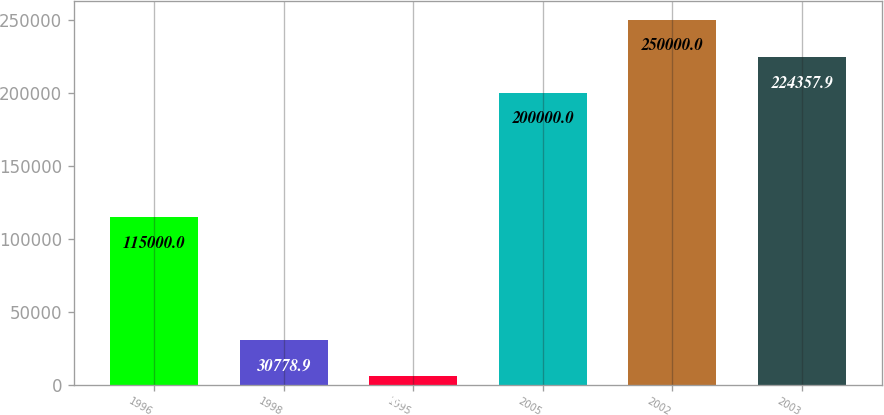Convert chart to OTSL. <chart><loc_0><loc_0><loc_500><loc_500><bar_chart><fcel>1996<fcel>1998<fcel>1995<fcel>2005<fcel>2002<fcel>2003<nl><fcel>115000<fcel>30778.9<fcel>6421<fcel>200000<fcel>250000<fcel>224358<nl></chart> 